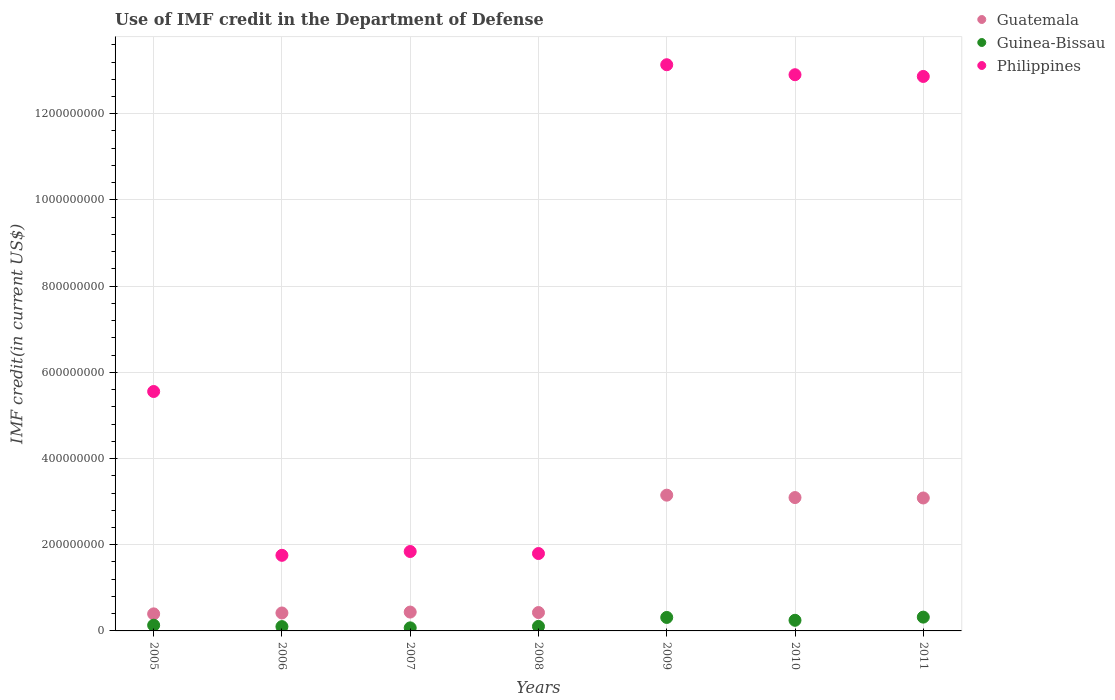Is the number of dotlines equal to the number of legend labels?
Keep it short and to the point. Yes. What is the IMF credit in the Department of Defense in Guinea-Bissau in 2009?
Make the answer very short. 3.13e+07. Across all years, what is the maximum IMF credit in the Department of Defense in Guatemala?
Your response must be concise. 3.15e+08. Across all years, what is the minimum IMF credit in the Department of Defense in Guinea-Bissau?
Your answer should be very brief. 7.11e+06. In which year was the IMF credit in the Department of Defense in Guinea-Bissau maximum?
Your answer should be compact. 2011. In which year was the IMF credit in the Department of Defense in Guinea-Bissau minimum?
Keep it short and to the point. 2007. What is the total IMF credit in the Department of Defense in Philippines in the graph?
Your answer should be very brief. 4.99e+09. What is the difference between the IMF credit in the Department of Defense in Guatemala in 2008 and that in 2010?
Your response must be concise. -2.67e+08. What is the difference between the IMF credit in the Department of Defense in Guatemala in 2010 and the IMF credit in the Department of Defense in Philippines in 2007?
Offer a terse response. 1.25e+08. What is the average IMF credit in the Department of Defense in Guinea-Bissau per year?
Your response must be concise. 1.84e+07. In the year 2007, what is the difference between the IMF credit in the Department of Defense in Guatemala and IMF credit in the Department of Defense in Guinea-Bissau?
Provide a succinct answer. 3.66e+07. What is the ratio of the IMF credit in the Department of Defense in Guinea-Bissau in 2005 to that in 2007?
Your answer should be very brief. 1.86. What is the difference between the highest and the second highest IMF credit in the Department of Defense in Philippines?
Provide a succinct answer. 2.32e+07. What is the difference between the highest and the lowest IMF credit in the Department of Defense in Guinea-Bissau?
Make the answer very short. 2.49e+07. In how many years, is the IMF credit in the Department of Defense in Guatemala greater than the average IMF credit in the Department of Defense in Guatemala taken over all years?
Provide a succinct answer. 3. Is the sum of the IMF credit in the Department of Defense in Guinea-Bissau in 2005 and 2010 greater than the maximum IMF credit in the Department of Defense in Philippines across all years?
Your response must be concise. No. Is it the case that in every year, the sum of the IMF credit in the Department of Defense in Philippines and IMF credit in the Department of Defense in Guinea-Bissau  is greater than the IMF credit in the Department of Defense in Guatemala?
Offer a very short reply. Yes. Is the IMF credit in the Department of Defense in Guinea-Bissau strictly greater than the IMF credit in the Department of Defense in Guatemala over the years?
Keep it short and to the point. No. Is the IMF credit in the Department of Defense in Guatemala strictly less than the IMF credit in the Department of Defense in Guinea-Bissau over the years?
Offer a very short reply. No. How many dotlines are there?
Offer a terse response. 3. How many years are there in the graph?
Your answer should be very brief. 7. What is the difference between two consecutive major ticks on the Y-axis?
Provide a short and direct response. 2.00e+08. Where does the legend appear in the graph?
Your answer should be very brief. Top right. How many legend labels are there?
Your answer should be compact. 3. What is the title of the graph?
Keep it short and to the point. Use of IMF credit in the Department of Defense. What is the label or title of the X-axis?
Your response must be concise. Years. What is the label or title of the Y-axis?
Ensure brevity in your answer.  IMF credit(in current US$). What is the IMF credit(in current US$) in Guatemala in 2005?
Give a very brief answer. 3.96e+07. What is the IMF credit(in current US$) in Guinea-Bissau in 2005?
Provide a short and direct response. 1.32e+07. What is the IMF credit(in current US$) in Philippines in 2005?
Provide a short and direct response. 5.55e+08. What is the IMF credit(in current US$) in Guatemala in 2006?
Ensure brevity in your answer.  4.16e+07. What is the IMF credit(in current US$) in Guinea-Bissau in 2006?
Make the answer very short. 1.00e+07. What is the IMF credit(in current US$) in Philippines in 2006?
Provide a succinct answer. 1.75e+08. What is the IMF credit(in current US$) in Guatemala in 2007?
Give a very brief answer. 4.37e+07. What is the IMF credit(in current US$) of Guinea-Bissau in 2007?
Provide a succinct answer. 7.11e+06. What is the IMF credit(in current US$) of Philippines in 2007?
Your answer should be very brief. 1.84e+08. What is the IMF credit(in current US$) of Guatemala in 2008?
Your answer should be compact. 4.26e+07. What is the IMF credit(in current US$) in Guinea-Bissau in 2008?
Keep it short and to the point. 1.05e+07. What is the IMF credit(in current US$) of Philippines in 2008?
Keep it short and to the point. 1.80e+08. What is the IMF credit(in current US$) of Guatemala in 2009?
Your answer should be very brief. 3.15e+08. What is the IMF credit(in current US$) of Guinea-Bissau in 2009?
Your answer should be compact. 3.13e+07. What is the IMF credit(in current US$) in Philippines in 2009?
Your answer should be very brief. 1.31e+09. What is the IMF credit(in current US$) of Guatemala in 2010?
Provide a succinct answer. 3.09e+08. What is the IMF credit(in current US$) in Guinea-Bissau in 2010?
Your answer should be very brief. 2.47e+07. What is the IMF credit(in current US$) in Philippines in 2010?
Keep it short and to the point. 1.29e+09. What is the IMF credit(in current US$) of Guatemala in 2011?
Keep it short and to the point. 3.08e+08. What is the IMF credit(in current US$) in Guinea-Bissau in 2011?
Ensure brevity in your answer.  3.20e+07. What is the IMF credit(in current US$) in Philippines in 2011?
Give a very brief answer. 1.29e+09. Across all years, what is the maximum IMF credit(in current US$) in Guatemala?
Make the answer very short. 3.15e+08. Across all years, what is the maximum IMF credit(in current US$) in Guinea-Bissau?
Your response must be concise. 3.20e+07. Across all years, what is the maximum IMF credit(in current US$) in Philippines?
Make the answer very short. 1.31e+09. Across all years, what is the minimum IMF credit(in current US$) in Guatemala?
Your answer should be very brief. 3.96e+07. Across all years, what is the minimum IMF credit(in current US$) in Guinea-Bissau?
Offer a terse response. 7.11e+06. Across all years, what is the minimum IMF credit(in current US$) of Philippines?
Your answer should be very brief. 1.75e+08. What is the total IMF credit(in current US$) in Guatemala in the graph?
Provide a succinct answer. 1.10e+09. What is the total IMF credit(in current US$) in Guinea-Bissau in the graph?
Offer a very short reply. 1.29e+08. What is the total IMF credit(in current US$) of Philippines in the graph?
Offer a terse response. 4.99e+09. What is the difference between the IMF credit(in current US$) in Guatemala in 2005 and that in 2006?
Offer a very short reply. -2.08e+06. What is the difference between the IMF credit(in current US$) in Guinea-Bissau in 2005 and that in 2006?
Your answer should be compact. 3.20e+06. What is the difference between the IMF credit(in current US$) in Philippines in 2005 and that in 2006?
Your answer should be very brief. 3.80e+08. What is the difference between the IMF credit(in current US$) of Guatemala in 2005 and that in 2007?
Your answer should be compact. -4.18e+06. What is the difference between the IMF credit(in current US$) in Guinea-Bissau in 2005 and that in 2007?
Provide a succinct answer. 6.12e+06. What is the difference between the IMF credit(in current US$) in Philippines in 2005 and that in 2007?
Keep it short and to the point. 3.71e+08. What is the difference between the IMF credit(in current US$) in Guatemala in 2005 and that in 2008?
Keep it short and to the point. -3.07e+06. What is the difference between the IMF credit(in current US$) in Guinea-Bissau in 2005 and that in 2008?
Offer a very short reply. 2.77e+06. What is the difference between the IMF credit(in current US$) in Philippines in 2005 and that in 2008?
Provide a short and direct response. 3.76e+08. What is the difference between the IMF credit(in current US$) of Guatemala in 2005 and that in 2009?
Keep it short and to the point. -2.75e+08. What is the difference between the IMF credit(in current US$) in Guinea-Bissau in 2005 and that in 2009?
Ensure brevity in your answer.  -1.80e+07. What is the difference between the IMF credit(in current US$) of Philippines in 2005 and that in 2009?
Provide a succinct answer. -7.58e+08. What is the difference between the IMF credit(in current US$) of Guatemala in 2005 and that in 2010?
Offer a very short reply. -2.70e+08. What is the difference between the IMF credit(in current US$) of Guinea-Bissau in 2005 and that in 2010?
Your answer should be compact. -1.14e+07. What is the difference between the IMF credit(in current US$) of Philippines in 2005 and that in 2010?
Your response must be concise. -7.35e+08. What is the difference between the IMF credit(in current US$) of Guatemala in 2005 and that in 2011?
Your answer should be compact. -2.69e+08. What is the difference between the IMF credit(in current US$) in Guinea-Bissau in 2005 and that in 2011?
Your answer should be compact. -1.88e+07. What is the difference between the IMF credit(in current US$) in Philippines in 2005 and that in 2011?
Provide a succinct answer. -7.31e+08. What is the difference between the IMF credit(in current US$) of Guatemala in 2006 and that in 2007?
Offer a terse response. -2.10e+06. What is the difference between the IMF credit(in current US$) of Guinea-Bissau in 2006 and that in 2007?
Your answer should be compact. 2.92e+06. What is the difference between the IMF credit(in current US$) of Philippines in 2006 and that in 2007?
Ensure brevity in your answer.  -8.84e+06. What is the difference between the IMF credit(in current US$) in Guatemala in 2006 and that in 2008?
Ensure brevity in your answer.  -9.93e+05. What is the difference between the IMF credit(in current US$) in Guinea-Bissau in 2006 and that in 2008?
Ensure brevity in your answer.  -4.32e+05. What is the difference between the IMF credit(in current US$) in Philippines in 2006 and that in 2008?
Your answer should be very brief. -4.18e+06. What is the difference between the IMF credit(in current US$) in Guatemala in 2006 and that in 2009?
Keep it short and to the point. -2.73e+08. What is the difference between the IMF credit(in current US$) of Guinea-Bissau in 2006 and that in 2009?
Keep it short and to the point. -2.12e+07. What is the difference between the IMF credit(in current US$) of Philippines in 2006 and that in 2009?
Your answer should be very brief. -1.14e+09. What is the difference between the IMF credit(in current US$) in Guatemala in 2006 and that in 2010?
Provide a short and direct response. -2.68e+08. What is the difference between the IMF credit(in current US$) of Guinea-Bissau in 2006 and that in 2010?
Provide a short and direct response. -1.46e+07. What is the difference between the IMF credit(in current US$) in Philippines in 2006 and that in 2010?
Keep it short and to the point. -1.12e+09. What is the difference between the IMF credit(in current US$) in Guatemala in 2006 and that in 2011?
Make the answer very short. -2.67e+08. What is the difference between the IMF credit(in current US$) of Guinea-Bissau in 2006 and that in 2011?
Ensure brevity in your answer.  -2.20e+07. What is the difference between the IMF credit(in current US$) of Philippines in 2006 and that in 2011?
Your response must be concise. -1.11e+09. What is the difference between the IMF credit(in current US$) of Guatemala in 2007 and that in 2008?
Give a very brief answer. 1.11e+06. What is the difference between the IMF credit(in current US$) in Guinea-Bissau in 2007 and that in 2008?
Give a very brief answer. -3.36e+06. What is the difference between the IMF credit(in current US$) of Philippines in 2007 and that in 2008?
Make the answer very short. 4.66e+06. What is the difference between the IMF credit(in current US$) of Guatemala in 2007 and that in 2009?
Provide a short and direct response. -2.71e+08. What is the difference between the IMF credit(in current US$) of Guinea-Bissau in 2007 and that in 2009?
Your answer should be very brief. -2.42e+07. What is the difference between the IMF credit(in current US$) of Philippines in 2007 and that in 2009?
Your answer should be very brief. -1.13e+09. What is the difference between the IMF credit(in current US$) of Guatemala in 2007 and that in 2010?
Provide a short and direct response. -2.66e+08. What is the difference between the IMF credit(in current US$) of Guinea-Bissau in 2007 and that in 2010?
Ensure brevity in your answer.  -1.76e+07. What is the difference between the IMF credit(in current US$) of Philippines in 2007 and that in 2010?
Offer a terse response. -1.11e+09. What is the difference between the IMF credit(in current US$) in Guatemala in 2007 and that in 2011?
Keep it short and to the point. -2.65e+08. What is the difference between the IMF credit(in current US$) in Guinea-Bissau in 2007 and that in 2011?
Your answer should be very brief. -2.49e+07. What is the difference between the IMF credit(in current US$) in Philippines in 2007 and that in 2011?
Your response must be concise. -1.10e+09. What is the difference between the IMF credit(in current US$) in Guatemala in 2008 and that in 2009?
Provide a succinct answer. -2.72e+08. What is the difference between the IMF credit(in current US$) in Guinea-Bissau in 2008 and that in 2009?
Ensure brevity in your answer.  -2.08e+07. What is the difference between the IMF credit(in current US$) of Philippines in 2008 and that in 2009?
Provide a short and direct response. -1.13e+09. What is the difference between the IMF credit(in current US$) of Guatemala in 2008 and that in 2010?
Give a very brief answer. -2.67e+08. What is the difference between the IMF credit(in current US$) in Guinea-Bissau in 2008 and that in 2010?
Your answer should be compact. -1.42e+07. What is the difference between the IMF credit(in current US$) in Philippines in 2008 and that in 2010?
Make the answer very short. -1.11e+09. What is the difference between the IMF credit(in current US$) in Guatemala in 2008 and that in 2011?
Your response must be concise. -2.66e+08. What is the difference between the IMF credit(in current US$) in Guinea-Bissau in 2008 and that in 2011?
Ensure brevity in your answer.  -2.15e+07. What is the difference between the IMF credit(in current US$) of Philippines in 2008 and that in 2011?
Your answer should be very brief. -1.11e+09. What is the difference between the IMF credit(in current US$) in Guatemala in 2009 and that in 2010?
Your answer should be compact. 5.56e+06. What is the difference between the IMF credit(in current US$) of Guinea-Bissau in 2009 and that in 2010?
Make the answer very short. 6.60e+06. What is the difference between the IMF credit(in current US$) of Philippines in 2009 and that in 2010?
Provide a short and direct response. 2.32e+07. What is the difference between the IMF credit(in current US$) of Guatemala in 2009 and that in 2011?
Give a very brief answer. 6.51e+06. What is the difference between the IMF credit(in current US$) in Guinea-Bissau in 2009 and that in 2011?
Offer a very short reply. -7.36e+05. What is the difference between the IMF credit(in current US$) of Philippines in 2009 and that in 2011?
Provide a short and direct response. 2.72e+07. What is the difference between the IMF credit(in current US$) of Guatemala in 2010 and that in 2011?
Provide a succinct answer. 9.56e+05. What is the difference between the IMF credit(in current US$) of Guinea-Bissau in 2010 and that in 2011?
Your answer should be very brief. -7.34e+06. What is the difference between the IMF credit(in current US$) of Philippines in 2010 and that in 2011?
Keep it short and to the point. 3.99e+06. What is the difference between the IMF credit(in current US$) in Guatemala in 2005 and the IMF credit(in current US$) in Guinea-Bissau in 2006?
Offer a terse response. 2.95e+07. What is the difference between the IMF credit(in current US$) of Guatemala in 2005 and the IMF credit(in current US$) of Philippines in 2006?
Make the answer very short. -1.36e+08. What is the difference between the IMF credit(in current US$) in Guinea-Bissau in 2005 and the IMF credit(in current US$) in Philippines in 2006?
Offer a terse response. -1.62e+08. What is the difference between the IMF credit(in current US$) of Guatemala in 2005 and the IMF credit(in current US$) of Guinea-Bissau in 2007?
Keep it short and to the point. 3.25e+07. What is the difference between the IMF credit(in current US$) of Guatemala in 2005 and the IMF credit(in current US$) of Philippines in 2007?
Your answer should be compact. -1.45e+08. What is the difference between the IMF credit(in current US$) of Guinea-Bissau in 2005 and the IMF credit(in current US$) of Philippines in 2007?
Make the answer very short. -1.71e+08. What is the difference between the IMF credit(in current US$) of Guatemala in 2005 and the IMF credit(in current US$) of Guinea-Bissau in 2008?
Keep it short and to the point. 2.91e+07. What is the difference between the IMF credit(in current US$) in Guatemala in 2005 and the IMF credit(in current US$) in Philippines in 2008?
Your answer should be compact. -1.40e+08. What is the difference between the IMF credit(in current US$) in Guinea-Bissau in 2005 and the IMF credit(in current US$) in Philippines in 2008?
Give a very brief answer. -1.66e+08. What is the difference between the IMF credit(in current US$) of Guatemala in 2005 and the IMF credit(in current US$) of Guinea-Bissau in 2009?
Provide a succinct answer. 8.29e+06. What is the difference between the IMF credit(in current US$) in Guatemala in 2005 and the IMF credit(in current US$) in Philippines in 2009?
Make the answer very short. -1.27e+09. What is the difference between the IMF credit(in current US$) in Guinea-Bissau in 2005 and the IMF credit(in current US$) in Philippines in 2009?
Ensure brevity in your answer.  -1.30e+09. What is the difference between the IMF credit(in current US$) in Guatemala in 2005 and the IMF credit(in current US$) in Guinea-Bissau in 2010?
Provide a succinct answer. 1.49e+07. What is the difference between the IMF credit(in current US$) of Guatemala in 2005 and the IMF credit(in current US$) of Philippines in 2010?
Ensure brevity in your answer.  -1.25e+09. What is the difference between the IMF credit(in current US$) in Guinea-Bissau in 2005 and the IMF credit(in current US$) in Philippines in 2010?
Ensure brevity in your answer.  -1.28e+09. What is the difference between the IMF credit(in current US$) of Guatemala in 2005 and the IMF credit(in current US$) of Guinea-Bissau in 2011?
Make the answer very short. 7.55e+06. What is the difference between the IMF credit(in current US$) of Guatemala in 2005 and the IMF credit(in current US$) of Philippines in 2011?
Keep it short and to the point. -1.25e+09. What is the difference between the IMF credit(in current US$) in Guinea-Bissau in 2005 and the IMF credit(in current US$) in Philippines in 2011?
Give a very brief answer. -1.27e+09. What is the difference between the IMF credit(in current US$) of Guatemala in 2006 and the IMF credit(in current US$) of Guinea-Bissau in 2007?
Provide a short and direct response. 3.45e+07. What is the difference between the IMF credit(in current US$) in Guatemala in 2006 and the IMF credit(in current US$) in Philippines in 2007?
Make the answer very short. -1.43e+08. What is the difference between the IMF credit(in current US$) in Guinea-Bissau in 2006 and the IMF credit(in current US$) in Philippines in 2007?
Offer a very short reply. -1.74e+08. What is the difference between the IMF credit(in current US$) of Guatemala in 2006 and the IMF credit(in current US$) of Guinea-Bissau in 2008?
Offer a terse response. 3.12e+07. What is the difference between the IMF credit(in current US$) in Guatemala in 2006 and the IMF credit(in current US$) in Philippines in 2008?
Provide a short and direct response. -1.38e+08. What is the difference between the IMF credit(in current US$) in Guinea-Bissau in 2006 and the IMF credit(in current US$) in Philippines in 2008?
Provide a succinct answer. -1.70e+08. What is the difference between the IMF credit(in current US$) of Guatemala in 2006 and the IMF credit(in current US$) of Guinea-Bissau in 2009?
Keep it short and to the point. 1.04e+07. What is the difference between the IMF credit(in current US$) in Guatemala in 2006 and the IMF credit(in current US$) in Philippines in 2009?
Give a very brief answer. -1.27e+09. What is the difference between the IMF credit(in current US$) of Guinea-Bissau in 2006 and the IMF credit(in current US$) of Philippines in 2009?
Offer a very short reply. -1.30e+09. What is the difference between the IMF credit(in current US$) of Guatemala in 2006 and the IMF credit(in current US$) of Guinea-Bissau in 2010?
Offer a terse response. 1.70e+07. What is the difference between the IMF credit(in current US$) of Guatemala in 2006 and the IMF credit(in current US$) of Philippines in 2010?
Offer a very short reply. -1.25e+09. What is the difference between the IMF credit(in current US$) in Guinea-Bissau in 2006 and the IMF credit(in current US$) in Philippines in 2010?
Your answer should be compact. -1.28e+09. What is the difference between the IMF credit(in current US$) of Guatemala in 2006 and the IMF credit(in current US$) of Guinea-Bissau in 2011?
Your answer should be very brief. 9.63e+06. What is the difference between the IMF credit(in current US$) in Guatemala in 2006 and the IMF credit(in current US$) in Philippines in 2011?
Give a very brief answer. -1.24e+09. What is the difference between the IMF credit(in current US$) of Guinea-Bissau in 2006 and the IMF credit(in current US$) of Philippines in 2011?
Offer a very short reply. -1.28e+09. What is the difference between the IMF credit(in current US$) in Guatemala in 2007 and the IMF credit(in current US$) in Guinea-Bissau in 2008?
Keep it short and to the point. 3.33e+07. What is the difference between the IMF credit(in current US$) of Guatemala in 2007 and the IMF credit(in current US$) of Philippines in 2008?
Make the answer very short. -1.36e+08. What is the difference between the IMF credit(in current US$) in Guinea-Bissau in 2007 and the IMF credit(in current US$) in Philippines in 2008?
Make the answer very short. -1.72e+08. What is the difference between the IMF credit(in current US$) of Guatemala in 2007 and the IMF credit(in current US$) of Guinea-Bissau in 2009?
Offer a terse response. 1.25e+07. What is the difference between the IMF credit(in current US$) of Guatemala in 2007 and the IMF credit(in current US$) of Philippines in 2009?
Give a very brief answer. -1.27e+09. What is the difference between the IMF credit(in current US$) of Guinea-Bissau in 2007 and the IMF credit(in current US$) of Philippines in 2009?
Your answer should be compact. -1.31e+09. What is the difference between the IMF credit(in current US$) in Guatemala in 2007 and the IMF credit(in current US$) in Guinea-Bissau in 2010?
Offer a terse response. 1.91e+07. What is the difference between the IMF credit(in current US$) in Guatemala in 2007 and the IMF credit(in current US$) in Philippines in 2010?
Keep it short and to the point. -1.25e+09. What is the difference between the IMF credit(in current US$) in Guinea-Bissau in 2007 and the IMF credit(in current US$) in Philippines in 2010?
Provide a succinct answer. -1.28e+09. What is the difference between the IMF credit(in current US$) in Guatemala in 2007 and the IMF credit(in current US$) in Guinea-Bissau in 2011?
Provide a succinct answer. 1.17e+07. What is the difference between the IMF credit(in current US$) in Guatemala in 2007 and the IMF credit(in current US$) in Philippines in 2011?
Your answer should be very brief. -1.24e+09. What is the difference between the IMF credit(in current US$) in Guinea-Bissau in 2007 and the IMF credit(in current US$) in Philippines in 2011?
Make the answer very short. -1.28e+09. What is the difference between the IMF credit(in current US$) in Guatemala in 2008 and the IMF credit(in current US$) in Guinea-Bissau in 2009?
Your answer should be compact. 1.14e+07. What is the difference between the IMF credit(in current US$) in Guatemala in 2008 and the IMF credit(in current US$) in Philippines in 2009?
Offer a very short reply. -1.27e+09. What is the difference between the IMF credit(in current US$) of Guinea-Bissau in 2008 and the IMF credit(in current US$) of Philippines in 2009?
Your answer should be very brief. -1.30e+09. What is the difference between the IMF credit(in current US$) of Guatemala in 2008 and the IMF credit(in current US$) of Guinea-Bissau in 2010?
Your response must be concise. 1.80e+07. What is the difference between the IMF credit(in current US$) of Guatemala in 2008 and the IMF credit(in current US$) of Philippines in 2010?
Give a very brief answer. -1.25e+09. What is the difference between the IMF credit(in current US$) in Guinea-Bissau in 2008 and the IMF credit(in current US$) in Philippines in 2010?
Give a very brief answer. -1.28e+09. What is the difference between the IMF credit(in current US$) in Guatemala in 2008 and the IMF credit(in current US$) in Guinea-Bissau in 2011?
Ensure brevity in your answer.  1.06e+07. What is the difference between the IMF credit(in current US$) of Guatemala in 2008 and the IMF credit(in current US$) of Philippines in 2011?
Give a very brief answer. -1.24e+09. What is the difference between the IMF credit(in current US$) in Guinea-Bissau in 2008 and the IMF credit(in current US$) in Philippines in 2011?
Provide a short and direct response. -1.28e+09. What is the difference between the IMF credit(in current US$) of Guatemala in 2009 and the IMF credit(in current US$) of Guinea-Bissau in 2010?
Your response must be concise. 2.90e+08. What is the difference between the IMF credit(in current US$) in Guatemala in 2009 and the IMF credit(in current US$) in Philippines in 2010?
Your answer should be compact. -9.76e+08. What is the difference between the IMF credit(in current US$) in Guinea-Bissau in 2009 and the IMF credit(in current US$) in Philippines in 2010?
Ensure brevity in your answer.  -1.26e+09. What is the difference between the IMF credit(in current US$) of Guatemala in 2009 and the IMF credit(in current US$) of Guinea-Bissau in 2011?
Your answer should be very brief. 2.83e+08. What is the difference between the IMF credit(in current US$) of Guatemala in 2009 and the IMF credit(in current US$) of Philippines in 2011?
Provide a succinct answer. -9.72e+08. What is the difference between the IMF credit(in current US$) in Guinea-Bissau in 2009 and the IMF credit(in current US$) in Philippines in 2011?
Offer a terse response. -1.26e+09. What is the difference between the IMF credit(in current US$) in Guatemala in 2010 and the IMF credit(in current US$) in Guinea-Bissau in 2011?
Your answer should be compact. 2.77e+08. What is the difference between the IMF credit(in current US$) of Guatemala in 2010 and the IMF credit(in current US$) of Philippines in 2011?
Provide a succinct answer. -9.77e+08. What is the difference between the IMF credit(in current US$) in Guinea-Bissau in 2010 and the IMF credit(in current US$) in Philippines in 2011?
Offer a terse response. -1.26e+09. What is the average IMF credit(in current US$) of Guatemala per year?
Keep it short and to the point. 1.57e+08. What is the average IMF credit(in current US$) of Guinea-Bissau per year?
Keep it short and to the point. 1.84e+07. What is the average IMF credit(in current US$) of Philippines per year?
Offer a very short reply. 7.12e+08. In the year 2005, what is the difference between the IMF credit(in current US$) of Guatemala and IMF credit(in current US$) of Guinea-Bissau?
Your response must be concise. 2.63e+07. In the year 2005, what is the difference between the IMF credit(in current US$) in Guatemala and IMF credit(in current US$) in Philippines?
Provide a succinct answer. -5.16e+08. In the year 2005, what is the difference between the IMF credit(in current US$) in Guinea-Bissau and IMF credit(in current US$) in Philippines?
Your response must be concise. -5.42e+08. In the year 2006, what is the difference between the IMF credit(in current US$) in Guatemala and IMF credit(in current US$) in Guinea-Bissau?
Your response must be concise. 3.16e+07. In the year 2006, what is the difference between the IMF credit(in current US$) of Guatemala and IMF credit(in current US$) of Philippines?
Your response must be concise. -1.34e+08. In the year 2006, what is the difference between the IMF credit(in current US$) in Guinea-Bissau and IMF credit(in current US$) in Philippines?
Provide a succinct answer. -1.65e+08. In the year 2007, what is the difference between the IMF credit(in current US$) of Guatemala and IMF credit(in current US$) of Guinea-Bissau?
Offer a very short reply. 3.66e+07. In the year 2007, what is the difference between the IMF credit(in current US$) in Guatemala and IMF credit(in current US$) in Philippines?
Give a very brief answer. -1.41e+08. In the year 2007, what is the difference between the IMF credit(in current US$) in Guinea-Bissau and IMF credit(in current US$) in Philippines?
Offer a very short reply. -1.77e+08. In the year 2008, what is the difference between the IMF credit(in current US$) in Guatemala and IMF credit(in current US$) in Guinea-Bissau?
Offer a very short reply. 3.22e+07. In the year 2008, what is the difference between the IMF credit(in current US$) in Guatemala and IMF credit(in current US$) in Philippines?
Provide a short and direct response. -1.37e+08. In the year 2008, what is the difference between the IMF credit(in current US$) in Guinea-Bissau and IMF credit(in current US$) in Philippines?
Give a very brief answer. -1.69e+08. In the year 2009, what is the difference between the IMF credit(in current US$) of Guatemala and IMF credit(in current US$) of Guinea-Bissau?
Your answer should be compact. 2.84e+08. In the year 2009, what is the difference between the IMF credit(in current US$) of Guatemala and IMF credit(in current US$) of Philippines?
Offer a very short reply. -9.99e+08. In the year 2009, what is the difference between the IMF credit(in current US$) in Guinea-Bissau and IMF credit(in current US$) in Philippines?
Your answer should be compact. -1.28e+09. In the year 2010, what is the difference between the IMF credit(in current US$) of Guatemala and IMF credit(in current US$) of Guinea-Bissau?
Ensure brevity in your answer.  2.85e+08. In the year 2010, what is the difference between the IMF credit(in current US$) of Guatemala and IMF credit(in current US$) of Philippines?
Provide a short and direct response. -9.81e+08. In the year 2010, what is the difference between the IMF credit(in current US$) in Guinea-Bissau and IMF credit(in current US$) in Philippines?
Offer a terse response. -1.27e+09. In the year 2011, what is the difference between the IMF credit(in current US$) of Guatemala and IMF credit(in current US$) of Guinea-Bissau?
Your response must be concise. 2.76e+08. In the year 2011, what is the difference between the IMF credit(in current US$) of Guatemala and IMF credit(in current US$) of Philippines?
Keep it short and to the point. -9.78e+08. In the year 2011, what is the difference between the IMF credit(in current US$) of Guinea-Bissau and IMF credit(in current US$) of Philippines?
Your answer should be very brief. -1.25e+09. What is the ratio of the IMF credit(in current US$) in Guatemala in 2005 to that in 2006?
Your response must be concise. 0.95. What is the ratio of the IMF credit(in current US$) in Guinea-Bissau in 2005 to that in 2006?
Give a very brief answer. 1.32. What is the ratio of the IMF credit(in current US$) of Philippines in 2005 to that in 2006?
Your answer should be very brief. 3.17. What is the ratio of the IMF credit(in current US$) of Guatemala in 2005 to that in 2007?
Provide a short and direct response. 0.9. What is the ratio of the IMF credit(in current US$) in Guinea-Bissau in 2005 to that in 2007?
Your answer should be compact. 1.86. What is the ratio of the IMF credit(in current US$) of Philippines in 2005 to that in 2007?
Your answer should be very brief. 3.01. What is the ratio of the IMF credit(in current US$) in Guatemala in 2005 to that in 2008?
Ensure brevity in your answer.  0.93. What is the ratio of the IMF credit(in current US$) of Guinea-Bissau in 2005 to that in 2008?
Your answer should be very brief. 1.26. What is the ratio of the IMF credit(in current US$) of Philippines in 2005 to that in 2008?
Ensure brevity in your answer.  3.09. What is the ratio of the IMF credit(in current US$) in Guatemala in 2005 to that in 2009?
Give a very brief answer. 0.13. What is the ratio of the IMF credit(in current US$) of Guinea-Bissau in 2005 to that in 2009?
Your answer should be compact. 0.42. What is the ratio of the IMF credit(in current US$) of Philippines in 2005 to that in 2009?
Your answer should be very brief. 0.42. What is the ratio of the IMF credit(in current US$) in Guatemala in 2005 to that in 2010?
Keep it short and to the point. 0.13. What is the ratio of the IMF credit(in current US$) of Guinea-Bissau in 2005 to that in 2010?
Provide a succinct answer. 0.54. What is the ratio of the IMF credit(in current US$) in Philippines in 2005 to that in 2010?
Your answer should be compact. 0.43. What is the ratio of the IMF credit(in current US$) of Guatemala in 2005 to that in 2011?
Provide a succinct answer. 0.13. What is the ratio of the IMF credit(in current US$) in Guinea-Bissau in 2005 to that in 2011?
Make the answer very short. 0.41. What is the ratio of the IMF credit(in current US$) of Philippines in 2005 to that in 2011?
Ensure brevity in your answer.  0.43. What is the ratio of the IMF credit(in current US$) in Guinea-Bissau in 2006 to that in 2007?
Give a very brief answer. 1.41. What is the ratio of the IMF credit(in current US$) in Philippines in 2006 to that in 2007?
Your answer should be very brief. 0.95. What is the ratio of the IMF credit(in current US$) of Guatemala in 2006 to that in 2008?
Make the answer very short. 0.98. What is the ratio of the IMF credit(in current US$) of Guinea-Bissau in 2006 to that in 2008?
Provide a succinct answer. 0.96. What is the ratio of the IMF credit(in current US$) in Philippines in 2006 to that in 2008?
Provide a short and direct response. 0.98. What is the ratio of the IMF credit(in current US$) of Guatemala in 2006 to that in 2009?
Make the answer very short. 0.13. What is the ratio of the IMF credit(in current US$) of Guinea-Bissau in 2006 to that in 2009?
Your answer should be very brief. 0.32. What is the ratio of the IMF credit(in current US$) in Philippines in 2006 to that in 2009?
Provide a succinct answer. 0.13. What is the ratio of the IMF credit(in current US$) of Guatemala in 2006 to that in 2010?
Offer a very short reply. 0.13. What is the ratio of the IMF credit(in current US$) in Guinea-Bissau in 2006 to that in 2010?
Provide a short and direct response. 0.41. What is the ratio of the IMF credit(in current US$) of Philippines in 2006 to that in 2010?
Offer a very short reply. 0.14. What is the ratio of the IMF credit(in current US$) in Guatemala in 2006 to that in 2011?
Your answer should be compact. 0.14. What is the ratio of the IMF credit(in current US$) of Guinea-Bissau in 2006 to that in 2011?
Offer a terse response. 0.31. What is the ratio of the IMF credit(in current US$) in Philippines in 2006 to that in 2011?
Offer a terse response. 0.14. What is the ratio of the IMF credit(in current US$) of Guatemala in 2007 to that in 2008?
Offer a very short reply. 1.03. What is the ratio of the IMF credit(in current US$) in Guinea-Bissau in 2007 to that in 2008?
Provide a succinct answer. 0.68. What is the ratio of the IMF credit(in current US$) of Guatemala in 2007 to that in 2009?
Make the answer very short. 0.14. What is the ratio of the IMF credit(in current US$) of Guinea-Bissau in 2007 to that in 2009?
Give a very brief answer. 0.23. What is the ratio of the IMF credit(in current US$) of Philippines in 2007 to that in 2009?
Your answer should be compact. 0.14. What is the ratio of the IMF credit(in current US$) in Guatemala in 2007 to that in 2010?
Ensure brevity in your answer.  0.14. What is the ratio of the IMF credit(in current US$) in Guinea-Bissau in 2007 to that in 2010?
Offer a terse response. 0.29. What is the ratio of the IMF credit(in current US$) of Philippines in 2007 to that in 2010?
Give a very brief answer. 0.14. What is the ratio of the IMF credit(in current US$) in Guatemala in 2007 to that in 2011?
Give a very brief answer. 0.14. What is the ratio of the IMF credit(in current US$) of Guinea-Bissau in 2007 to that in 2011?
Offer a very short reply. 0.22. What is the ratio of the IMF credit(in current US$) in Philippines in 2007 to that in 2011?
Make the answer very short. 0.14. What is the ratio of the IMF credit(in current US$) in Guatemala in 2008 to that in 2009?
Keep it short and to the point. 0.14. What is the ratio of the IMF credit(in current US$) in Guinea-Bissau in 2008 to that in 2009?
Make the answer very short. 0.33. What is the ratio of the IMF credit(in current US$) in Philippines in 2008 to that in 2009?
Offer a very short reply. 0.14. What is the ratio of the IMF credit(in current US$) of Guatemala in 2008 to that in 2010?
Ensure brevity in your answer.  0.14. What is the ratio of the IMF credit(in current US$) of Guinea-Bissau in 2008 to that in 2010?
Ensure brevity in your answer.  0.42. What is the ratio of the IMF credit(in current US$) of Philippines in 2008 to that in 2010?
Provide a short and direct response. 0.14. What is the ratio of the IMF credit(in current US$) in Guatemala in 2008 to that in 2011?
Make the answer very short. 0.14. What is the ratio of the IMF credit(in current US$) of Guinea-Bissau in 2008 to that in 2011?
Offer a terse response. 0.33. What is the ratio of the IMF credit(in current US$) of Philippines in 2008 to that in 2011?
Your answer should be compact. 0.14. What is the ratio of the IMF credit(in current US$) of Guinea-Bissau in 2009 to that in 2010?
Offer a terse response. 1.27. What is the ratio of the IMF credit(in current US$) of Philippines in 2009 to that in 2010?
Provide a short and direct response. 1.02. What is the ratio of the IMF credit(in current US$) of Guatemala in 2009 to that in 2011?
Your answer should be very brief. 1.02. What is the ratio of the IMF credit(in current US$) of Guinea-Bissau in 2009 to that in 2011?
Make the answer very short. 0.98. What is the ratio of the IMF credit(in current US$) of Philippines in 2009 to that in 2011?
Your answer should be very brief. 1.02. What is the ratio of the IMF credit(in current US$) in Guatemala in 2010 to that in 2011?
Keep it short and to the point. 1. What is the ratio of the IMF credit(in current US$) in Guinea-Bissau in 2010 to that in 2011?
Your response must be concise. 0.77. What is the ratio of the IMF credit(in current US$) in Philippines in 2010 to that in 2011?
Provide a succinct answer. 1. What is the difference between the highest and the second highest IMF credit(in current US$) in Guatemala?
Provide a succinct answer. 5.56e+06. What is the difference between the highest and the second highest IMF credit(in current US$) of Guinea-Bissau?
Provide a succinct answer. 7.36e+05. What is the difference between the highest and the second highest IMF credit(in current US$) in Philippines?
Keep it short and to the point. 2.32e+07. What is the difference between the highest and the lowest IMF credit(in current US$) of Guatemala?
Your response must be concise. 2.75e+08. What is the difference between the highest and the lowest IMF credit(in current US$) in Guinea-Bissau?
Make the answer very short. 2.49e+07. What is the difference between the highest and the lowest IMF credit(in current US$) of Philippines?
Give a very brief answer. 1.14e+09. 